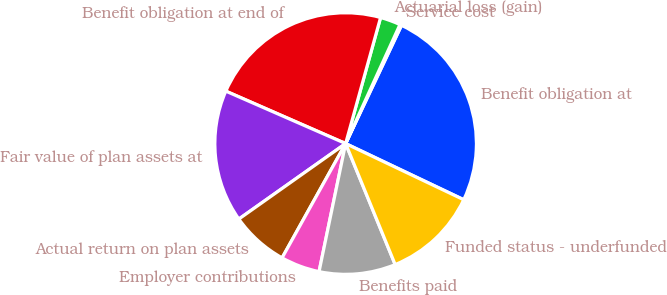<chart> <loc_0><loc_0><loc_500><loc_500><pie_chart><fcel>Benefit obligation at<fcel>Service cost<fcel>Actuarial loss (gain)<fcel>Benefit obligation at end of<fcel>Fair value of plan assets at<fcel>Actual return on plan assets<fcel>Employer contributions<fcel>Benefits paid<fcel>Funded status - underfunded<nl><fcel>25.04%<fcel>0.21%<fcel>2.51%<fcel>22.74%<fcel>16.36%<fcel>7.13%<fcel>4.82%<fcel>9.44%<fcel>11.75%<nl></chart> 